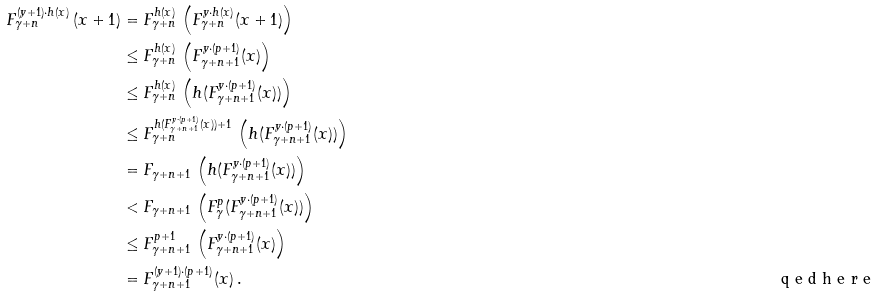<formula> <loc_0><loc_0><loc_500><loc_500>\, F _ { \gamma + n } ^ { ( y + 1 ) \cdot h ( x ) } \, ( x + 1 ) & = F _ { \gamma + n } ^ { h ( x ) } \, \left ( F _ { \gamma + n } ^ { y \cdot h ( x ) } ( x + 1 ) \right ) \\ & \leq F _ { \gamma + n } ^ { h ( x ) } \, \left ( F _ { \gamma + n + 1 } ^ { y \cdot ( p + 1 ) } ( x ) \right ) \\ & \leq F _ { \gamma + n } ^ { h ( x ) } \, \left ( h ( F _ { \gamma + n + 1 } ^ { y \cdot ( p + 1 ) } ( x ) ) \right ) \\ & \leq F _ { \gamma + n } ^ { h ( F _ { \gamma + n + 1 } ^ { y \cdot ( p + 1 ) } ( x ) ) + 1 } \, \left ( h ( F _ { \gamma + n + 1 } ^ { y \cdot ( p + 1 ) } ( x ) ) \right ) \\ & = F _ { \gamma + n + 1 } \, \left ( h ( F _ { \gamma + n + 1 } ^ { y \cdot ( p + 1 ) } ( x ) ) \right ) \\ & < F _ { \gamma + n + 1 } \, \left ( F _ { \gamma } ^ { p } ( F _ { \gamma + n + 1 } ^ { y \cdot ( p + 1 ) } ( x ) ) \right ) \\ & \leq F _ { \gamma + n + 1 } ^ { p + 1 } \, \left ( F _ { \gamma + n + 1 } ^ { y \cdot ( p + 1 ) } ( x ) \right ) \\ & = F _ { \gamma + n + 1 } ^ { ( y + 1 ) \cdot ( p + 1 ) } ( x ) \, . \tag* { \ q e d h e r e }</formula> 